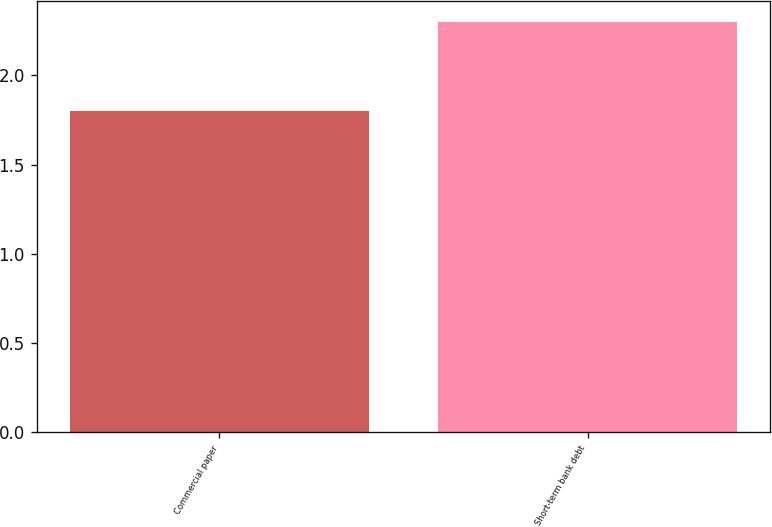<chart> <loc_0><loc_0><loc_500><loc_500><bar_chart><fcel>Commercial paper<fcel>Short-term bank debt<nl><fcel>1.8<fcel>2.3<nl></chart> 